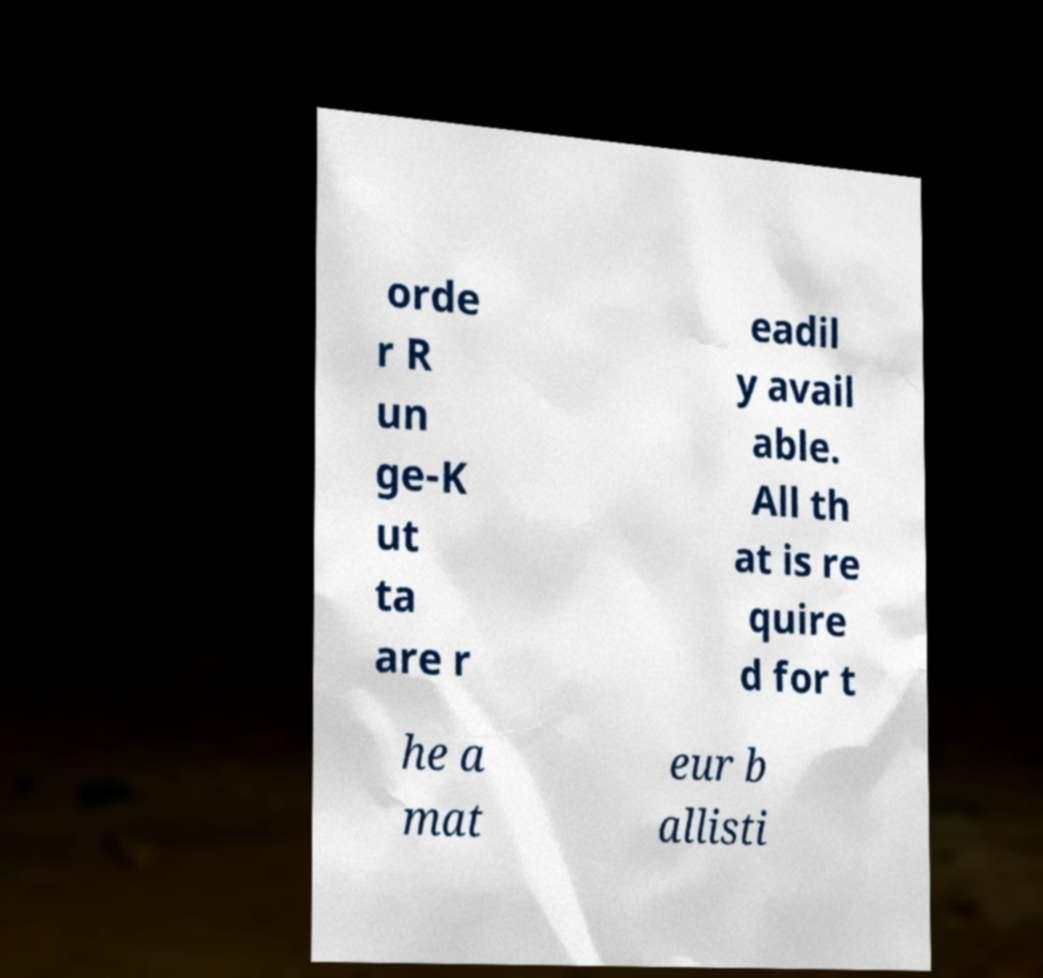Please identify and transcribe the text found in this image. orde r R un ge-K ut ta are r eadil y avail able. All th at is re quire d for t he a mat eur b allisti 